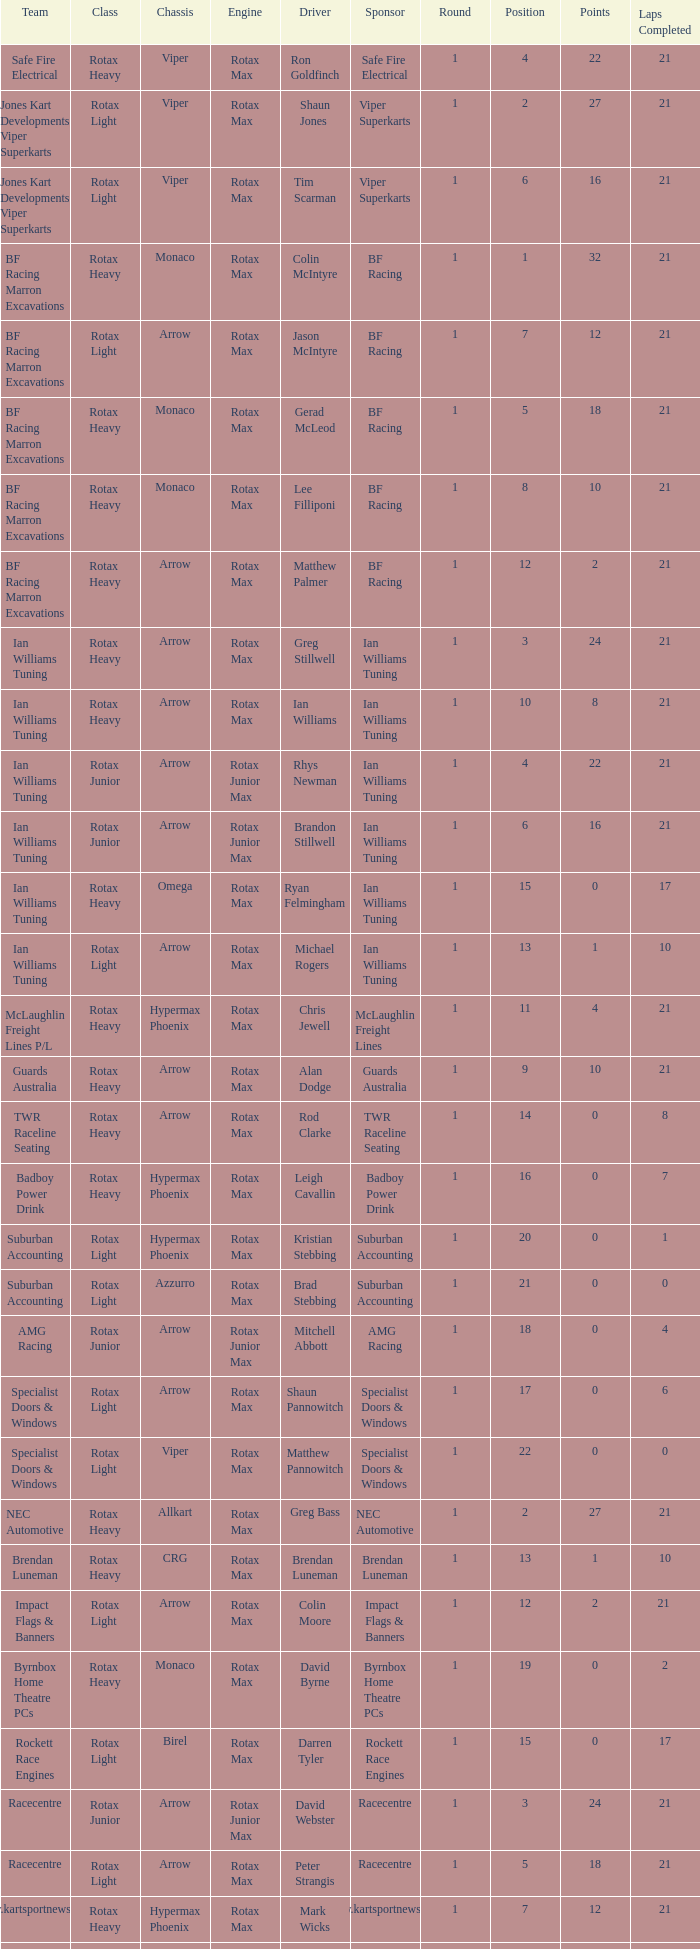Can you parse all the data within this table? {'header': ['Team', 'Class', 'Chassis', 'Engine', 'Driver', 'Sponsor', 'Round', 'Position', 'Points', 'Laps Completed'], 'rows': [['Safe Fire Electrical', 'Rotax Heavy', 'Viper', 'Rotax Max', 'Ron Goldfinch', 'Safe Fire Electrical', '1', '4', '22', '21'], ['Jones Kart Developments Viper Superkarts', 'Rotax Light', 'Viper', 'Rotax Max', 'Shaun Jones', 'Viper Superkarts', '1', '2', '27', '21'], ['Jones Kart Developments Viper Superkarts', 'Rotax Light', 'Viper', 'Rotax Max', 'Tim Scarman', 'Viper Superkarts', '1', '6', '16', '21'], ['BF Racing Marron Excavations', 'Rotax Heavy', 'Monaco', 'Rotax Max', 'Colin McIntyre', 'BF Racing', '1', '1', '32', '21'], ['BF Racing Marron Excavations', 'Rotax Light', 'Arrow', 'Rotax Max', 'Jason McIntyre', 'BF Racing', '1', '7', '12', '21'], ['BF Racing Marron Excavations', 'Rotax Heavy', 'Monaco', 'Rotax Max', 'Gerad McLeod', 'BF Racing', '1', '5', '18', '21'], ['BF Racing Marron Excavations', 'Rotax Heavy', 'Monaco', 'Rotax Max', 'Lee Filliponi', 'BF Racing', '1', '8', '10', '21'], ['BF Racing Marron Excavations', 'Rotax Heavy', 'Arrow', 'Rotax Max', 'Matthew Palmer', 'BF Racing', '1', '12', '2', '21'], ['Ian Williams Tuning', 'Rotax Heavy', 'Arrow', 'Rotax Max', 'Greg Stillwell', 'Ian Williams Tuning', '1', '3', '24', '21'], ['Ian Williams Tuning', 'Rotax Heavy', 'Arrow', 'Rotax Max', 'Ian Williams', 'Ian Williams Tuning', '1', '10', '8', '21'], ['Ian Williams Tuning', 'Rotax Junior', 'Arrow', 'Rotax Junior Max', 'Rhys Newman', 'Ian Williams Tuning', '1', '4', '22', '21'], ['Ian Williams Tuning', 'Rotax Junior', 'Arrow', 'Rotax Junior Max', 'Brandon Stillwell', 'Ian Williams Tuning', '1', '6', '16', '21'], ['Ian Williams Tuning', 'Rotax Heavy', 'Omega', 'Rotax Max', 'Ryan Felmingham', 'Ian Williams Tuning', '1', '15', '0', '17'], ['Ian Williams Tuning', 'Rotax Light', 'Arrow', 'Rotax Max', 'Michael Rogers', 'Ian Williams Tuning', '1', '13', '1', '10'], ['McLaughlin Freight Lines P/L', 'Rotax Heavy', 'Hypermax Phoenix', 'Rotax Max', 'Chris Jewell', 'McLaughlin Freight Lines', '1', '11', '4', '21'], ['Guards Australia', 'Rotax Heavy', 'Arrow', 'Rotax Max', 'Alan Dodge', 'Guards Australia', '1', '9', '10', '21'], ['TWR Raceline Seating', 'Rotax Heavy', 'Arrow', 'Rotax Max', 'Rod Clarke', 'TWR Raceline Seating', '1', '14', '0', '8'], ['Badboy Power Drink', 'Rotax Heavy', 'Hypermax Phoenix', 'Rotax Max', 'Leigh Cavallin', 'Badboy Power Drink', '1', '16', '0', '7'], ['Suburban Accounting', 'Rotax Light', 'Hypermax Phoenix', 'Rotax Max', 'Kristian Stebbing', 'Suburban Accounting', '1', '20', '0', '1'], ['Suburban Accounting', 'Rotax Light', 'Azzurro', 'Rotax Max', 'Brad Stebbing', 'Suburban Accounting', '1', '21', '0', '0'], ['AMG Racing', 'Rotax Junior', 'Arrow', 'Rotax Junior Max', 'Mitchell Abbott', 'AMG Racing', '1', '18', '0', '4'], ['Specialist Doors & Windows', 'Rotax Light', 'Arrow', 'Rotax Max', 'Shaun Pannowitch', 'Specialist Doors & Windows', '1', '17', '0', '6'], ['Specialist Doors & Windows', 'Rotax Light', 'Viper', 'Rotax Max', 'Matthew Pannowitch', 'Specialist Doors & Windows', '1', '22', '0', '0'], ['NEC Automotive', 'Rotax Heavy', 'Allkart', 'Rotax Max', 'Greg Bass', 'NEC Automotive', '1', '2', '27', '21'], ['Brendan Luneman', 'Rotax Heavy', 'CRG', 'Rotax Max', 'Brendan Luneman', 'Brendan Luneman', '1', '13', '1', '10'], ['Impact Flags & Banners', 'Rotax Light', 'Arrow', 'Rotax Max', 'Colin Moore', 'Impact Flags & Banners', '1', '12', '2', '21 '], ['Byrnbox Home Theatre PCs', 'Rotax Heavy', 'Monaco', 'Rotax Max', 'David Byrne', 'Byrnbox Home Theatre PCs', '1', '19', '0', '2'], ['Rockett Race Engines', 'Rotax Light', 'Birel', 'Rotax Max', 'Darren Tyler', 'Rockett Race Engines', '1', '15', '0', '17'], ['Racecentre', 'Rotax Junior', 'Arrow', 'Rotax Junior Max', 'David Webster', 'Racecentre', '1', '3', '24', '21'], ['Racecentre', 'Rotax Light', 'Arrow', 'Rotax Max', 'Peter Strangis', 'Racecentre', '1', '5', '18', '21'], ['www.kartsportnews.com', 'Rotax Heavy', 'Hypermax Phoenix', 'Rotax Max', 'Mark Wicks', 'www.kartsportnews.com', '1', '7', '12', '21'], ['Doug Savage', 'Rotax Light', 'Arrow', 'Rotax Max', 'Doug Savage', 'Doug Savage', '1', '23', '0', '0'], ['Race Stickerz Toyota Material Handling', 'Rotax Heavy', 'Techno', 'Rotax Max', 'Scott Appledore', 'Race Stickerz Toyota Material Handling', '1', '18', '0', '4'], ['Wild Digital', 'Rotax Junior', 'Hypermax Phoenix', 'Rotax Junior Max', 'Sean Whitfield', 'Wild Digital', '1', '11', '4', '21'], ['John Bartlett', 'Rotax Heavy', 'Hypermax Phoenix', 'Rotax Max', 'John Bartlett', 'John Bartlett', '1', '17', '0', '6']]} What is the name of the driver with a rotax max engine, in the rotax heavy class, with arrow as chassis and on the TWR Raceline Seating team? Rod Clarke. 